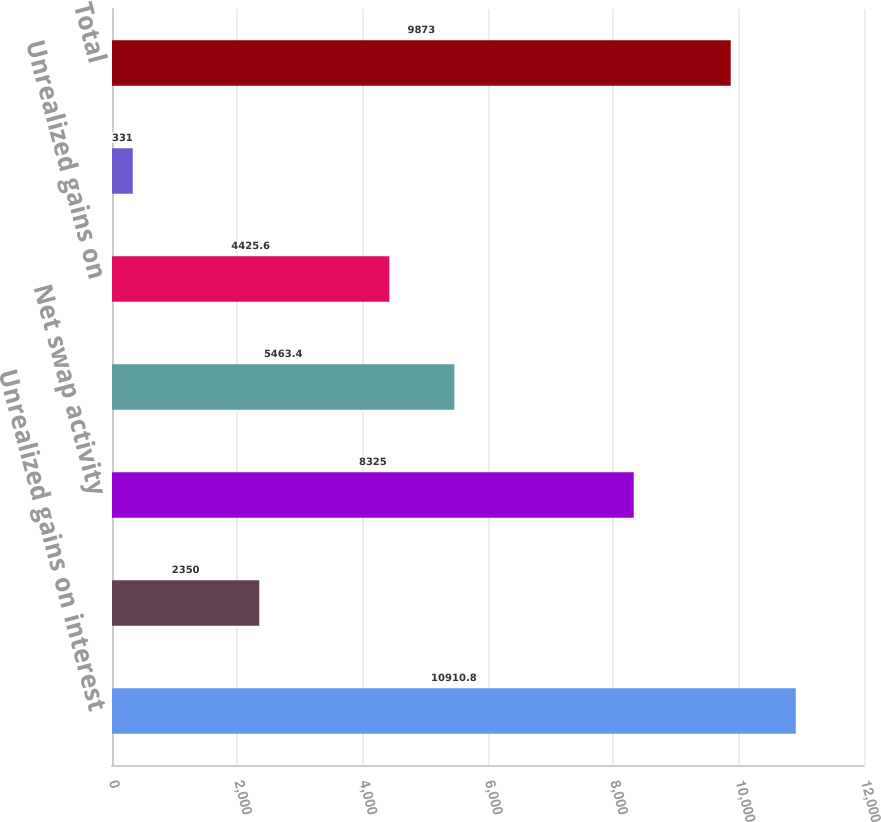Convert chart to OTSL. <chart><loc_0><loc_0><loc_500><loc_500><bar_chart><fcel>Unrealized gains on interest<fcel>Less reclassification of net<fcel>Net swap activity<fcel>Unrealized losses on interest<fcel>Unrealized gains on<fcel>Net investment activity<fcel>Total<nl><fcel>10910.8<fcel>2350<fcel>8325<fcel>5463.4<fcel>4425.6<fcel>331<fcel>9873<nl></chart> 